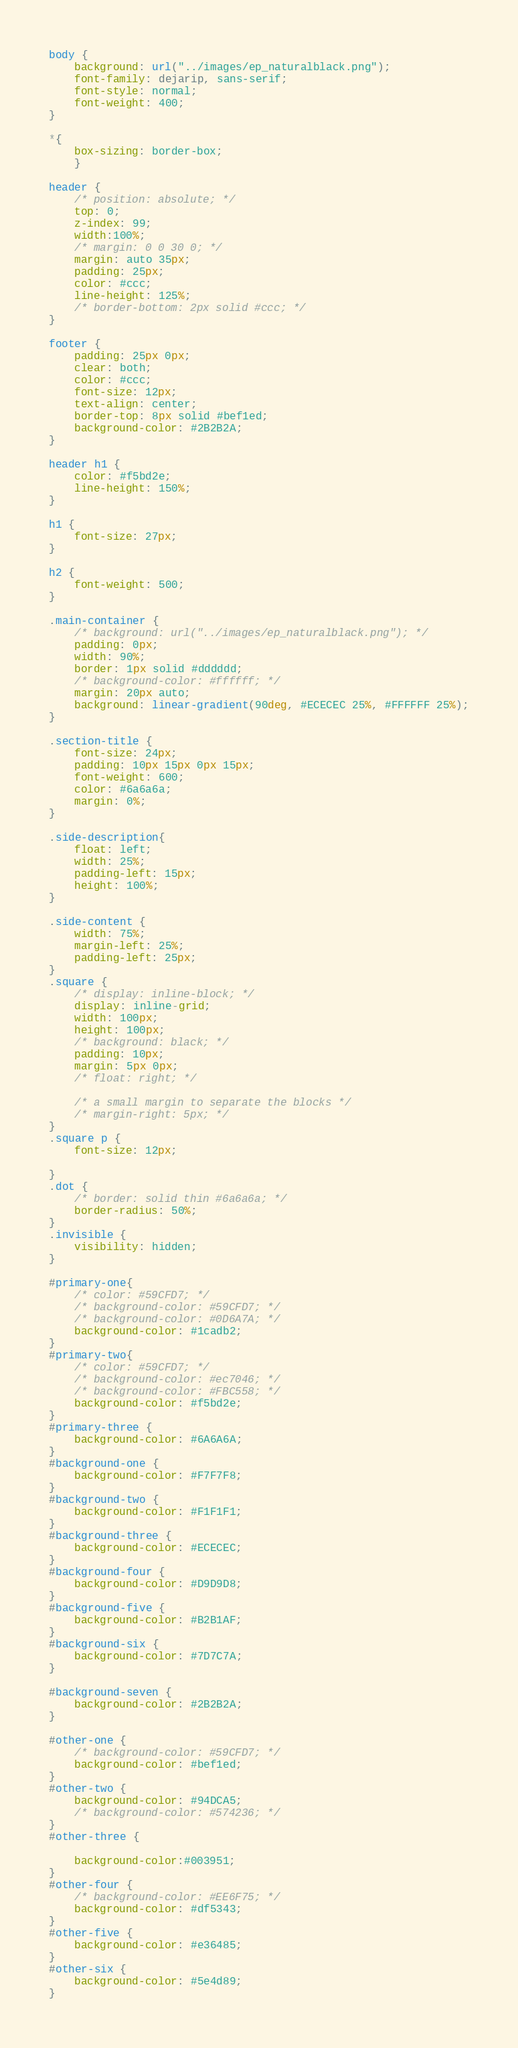Convert code to text. <code><loc_0><loc_0><loc_500><loc_500><_CSS_>body {
    background: url("../images/ep_naturalblack.png");
    font-family: dejarip, sans-serif;
    font-style: normal;
    font-weight: 400;
}

*{
    box-sizing: border-box;
    }

header {
    /* position: absolute; */
    top: 0;
	z-index: 99;
    width:100%;
    /* margin: 0 0 30 0; */
    margin: auto 35px;
    padding: 25px;
    color: #ccc;
    line-height: 125%;
	/* border-bottom: 2px solid #ccc; */
}

footer {
	padding: 25px 0px;
	clear: both;
	color: #ccc;
	font-size: 12px;
	text-align: center;
    border-top: 8px solid #bef1ed;
    background-color: #2B2B2A;
}

header h1 {
    color: #f5bd2e;
    line-height: 150%;
}

h1 {
    font-size: 27px;
}

h2 {
    font-weight: 500;
}

.main-container {
	/* background: url("../images/ep_naturalblack.png"); */
	padding: 0px;
    width: 90%;
	border: 1px solid #dddddd;
    /* background-color: #ffffff; */
    margin: 20px auto; 
    background: linear-gradient(90deg, #ECECEC 25%, #FFFFFF 25%);
}

.section-title {
    font-size: 24px;
    padding: 10px 15px 0px 15px;
    font-weight: 600;
    color: #6a6a6a;
    margin: 0%;
}

.side-description{
    float: left;
    width: 25%;
    padding-left: 15px;
    height: 100%;
}

.side-content {
    width: 75%;
    margin-left: 25%;
    padding-left: 25px;
}
.square {
    /* display: inline-block; */
    display: inline-grid;
    width: 100px;
    height: 100px;
    /* background: black; */
    padding: 10px;
    margin: 5px 0px;
    /* float: right; */

    /* a small margin to separate the blocks */
    /* margin-right: 5px; */
}
.square p {
    font-size: 12px;

}
.dot {
    /* border: solid thin #6a6a6a; */
    border-radius: 50%;
}
.invisible {
    visibility: hidden;
}

#primary-one{
    /* color: #59CFD7; */
    /* background-color: #59CFD7; */
    /* background-color: #0D6A7A; */
    background-color: #1cadb2;
}
#primary-two{
    /* color: #59CFD7; */
    /* background-color: #ec7046; */
    /* background-color: #FBC558; */
    background-color: #f5bd2e;
}
#primary-three {
    background-color: #6A6A6A;
}
#background-one {
    background-color: #F7F7F8;
}
#background-two {
    background-color: #F1F1F1;
}
#background-three {
    background-color: #ECECEC;
}
#background-four {
    background-color: #D9D9D8;
}
#background-five {
    background-color: #B2B1AF;
}
#background-six {
    background-color: #7D7C7A;
}

#background-seven {
    background-color: #2B2B2A;
}

#other-one {
    /* background-color: #59CFD7; */
    background-color: #bef1ed;
}
#other-two {
    background-color: #94DCA5;
    /* background-color: #574236; */
}
#other-three {
    
    background-color:#003951;
}
#other-four {
    /* background-color: #EE6F75; */
    background-color: #df5343;
}
#other-five {
    background-color: #e36485;
}
#other-six {
    background-color: #5e4d89;
}</code> 